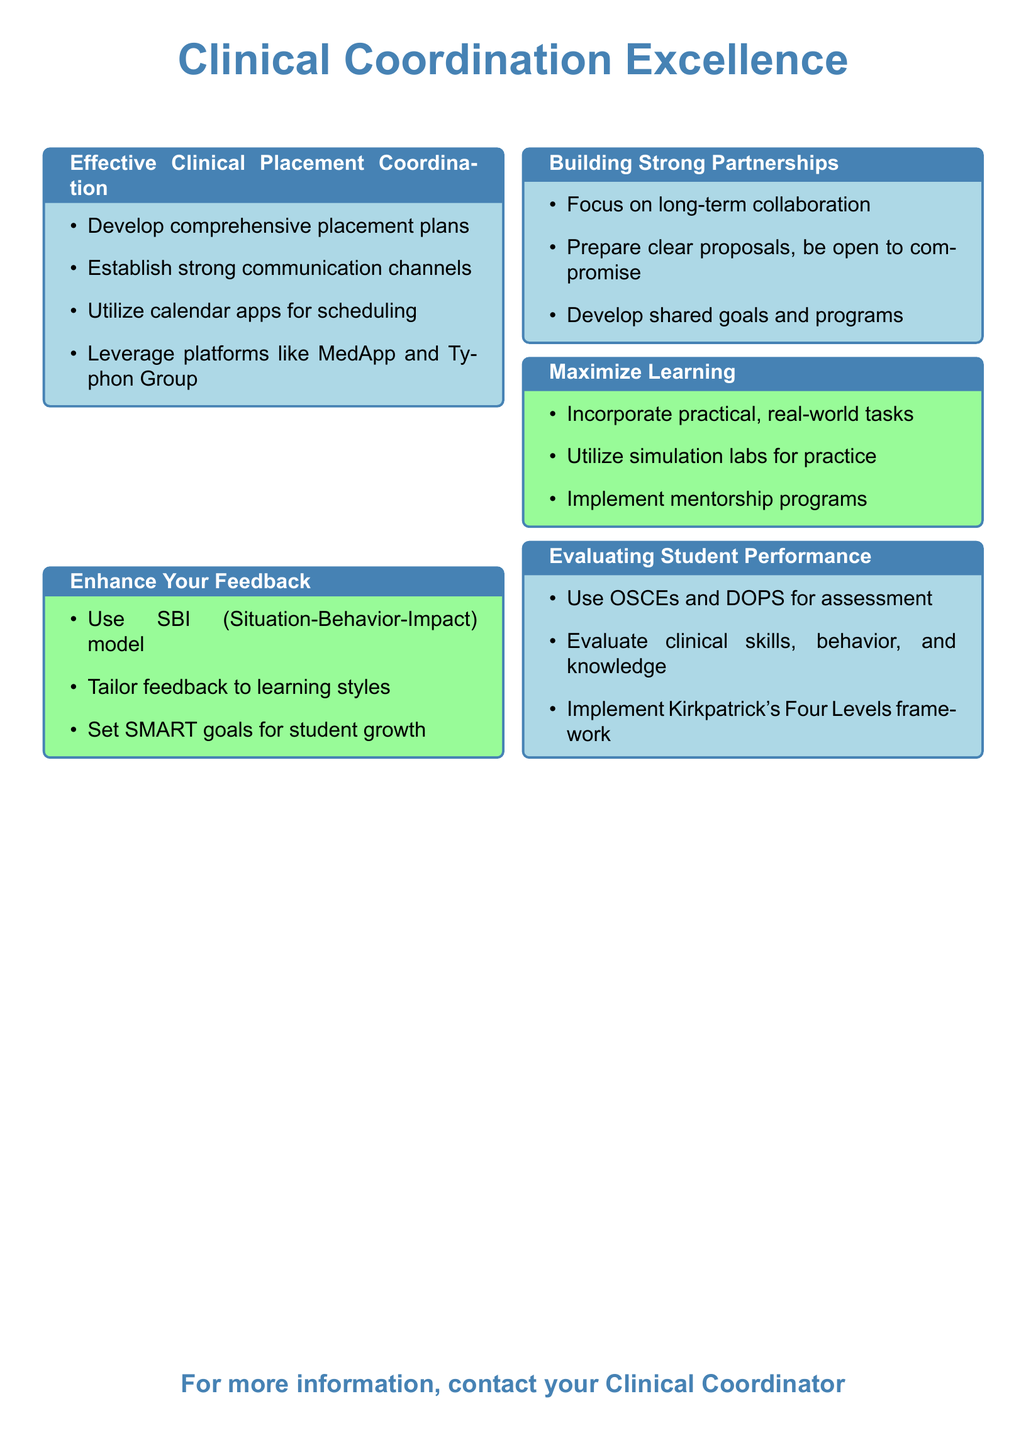What is the title of the flyer? The title of the flyer is prominently displayed at the top and is "Clinical Coordination Excellence".
Answer: Clinical Coordination Excellence What color is used for the boxes in the flyer? The boxes in the flyer are colored light blue and pale green, as indicated in the design elements of the document.
Answer: Light blue and pale green What is one tool suggested to streamline coordination processes? The document mentions specific digital tools such as MedApp and Typhon Group for clinical placement coordination.
Answer: MedApp What model is recommended for providing feedback? The flyer suggests using the SBI (Situation-Behavior-Impact) model for giving feedback to students.
Answer: SBI model What framework is mentioned for evaluating student performance? The document references Kirkpatrick's Four Levels framework as a method for evaluating student competencies.
Answer: Kirkpatrick's Four Levels How can feedback be tailored according to the flyer? The flyer advises tailoring feedback to different learning styles of students to enhance their understanding and growth.
Answer: Learning styles Which strategy is suggested for building partnerships with healthcare facilities? The flyer emphasizes the importance of preparing clear proposals and being open to compromise to build solid partnerships.
Answer: Clear proposals What type of training is emphasized for maximizing learning? The document focuses on on-the-job training strategies, including hands-on activities and mentorship programs for effective learning.
Answer: On-the-job training What is one method to assess clinical skills mentioned in the flyer? The flyer mentions using OSCEs (Objective Structured Clinical Examinations) as a method for assessing clinical skills among students.
Answer: OSCEs 